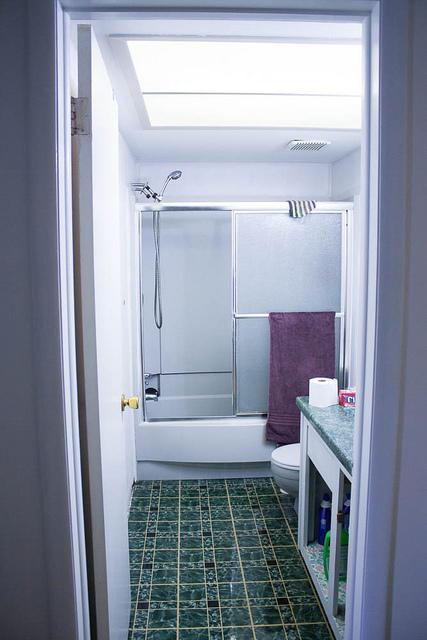How many towels are on the road?
Write a very short answer. 1. What room is in the photograph?
Concise answer only. Bathroom. What color is the floor tile?
Quick response, please. Green. 